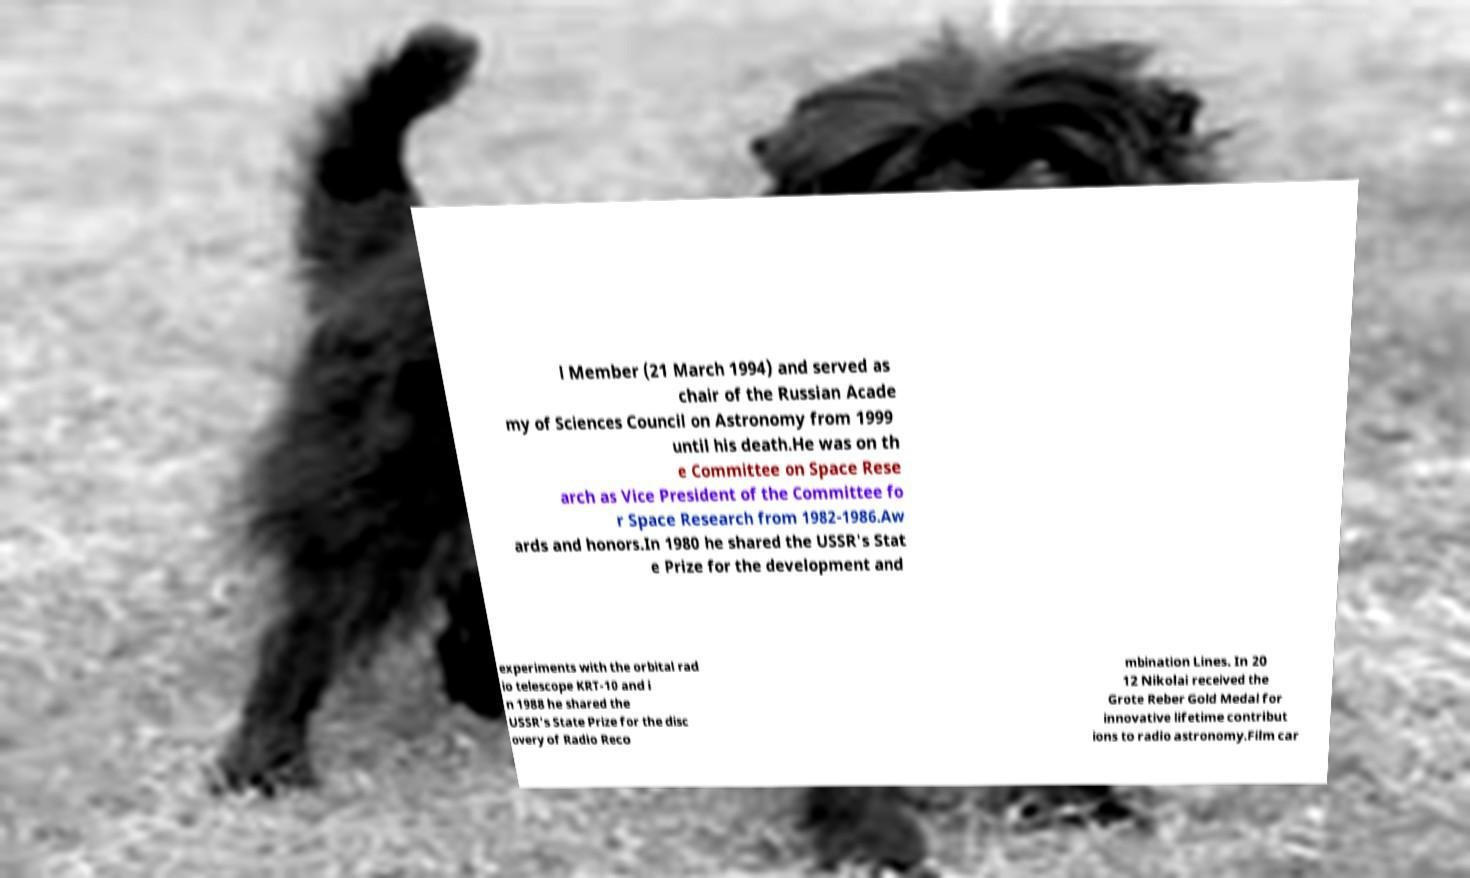There's text embedded in this image that I need extracted. Can you transcribe it verbatim? l Member (21 March 1994) and served as chair of the Russian Acade my of Sciences Council on Astronomy from 1999 until his death.He was on th e Committee on Space Rese arch as Vice President of the Committee fo r Space Research from 1982-1986.Aw ards and honors.In 1980 he shared the USSR's Stat e Prize for the development and experiments with the orbital rad io telescope KRT-10 and i n 1988 he shared the USSR's State Prize for the disc overy of Radio Reco mbination Lines. In 20 12 Nikolai received the Grote Reber Gold Medal for innovative lifetime contribut ions to radio astronomy.Film car 